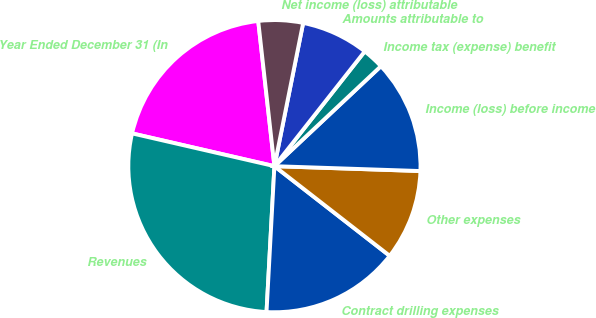Convert chart. <chart><loc_0><loc_0><loc_500><loc_500><pie_chart><fcel>Year Ended December 31 (In<fcel>Revenues<fcel>Contract drilling expenses<fcel>Other expenses<fcel>Income (loss) before income<fcel>Income tax (expense) benefit<fcel>Amounts attributable to<fcel>Net income (loss) attributable<nl><fcel>19.63%<fcel>27.74%<fcel>15.34%<fcel>9.99%<fcel>12.53%<fcel>2.39%<fcel>7.46%<fcel>4.92%<nl></chart> 